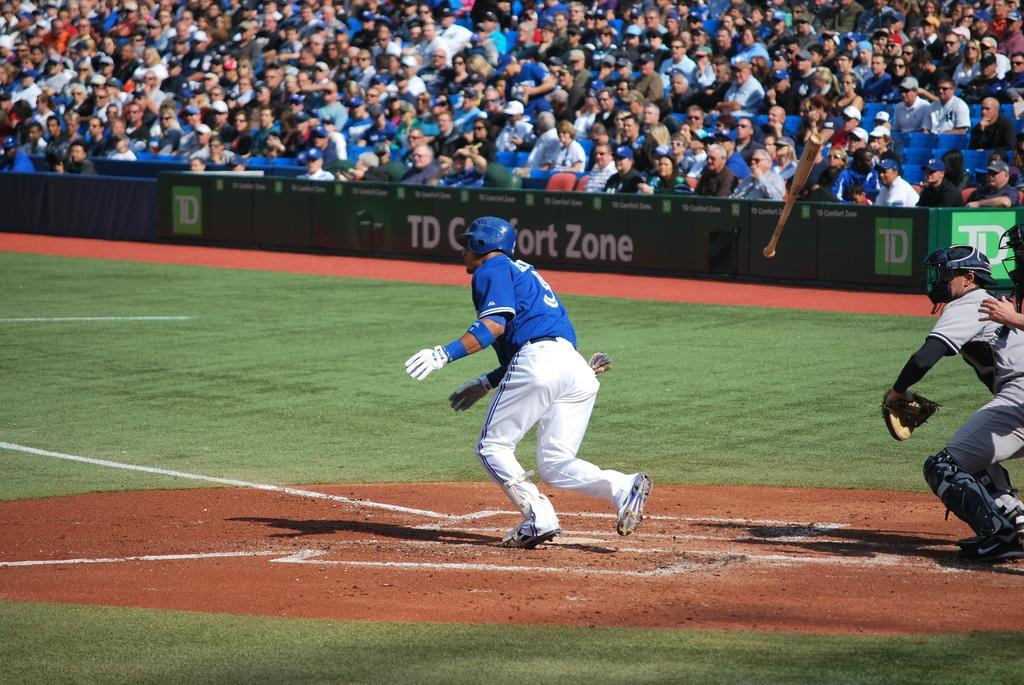Can you describe this image briefly? This image is taken in a stadium. In this image there are a few players running on the ground. In the background there are a few spectators. 